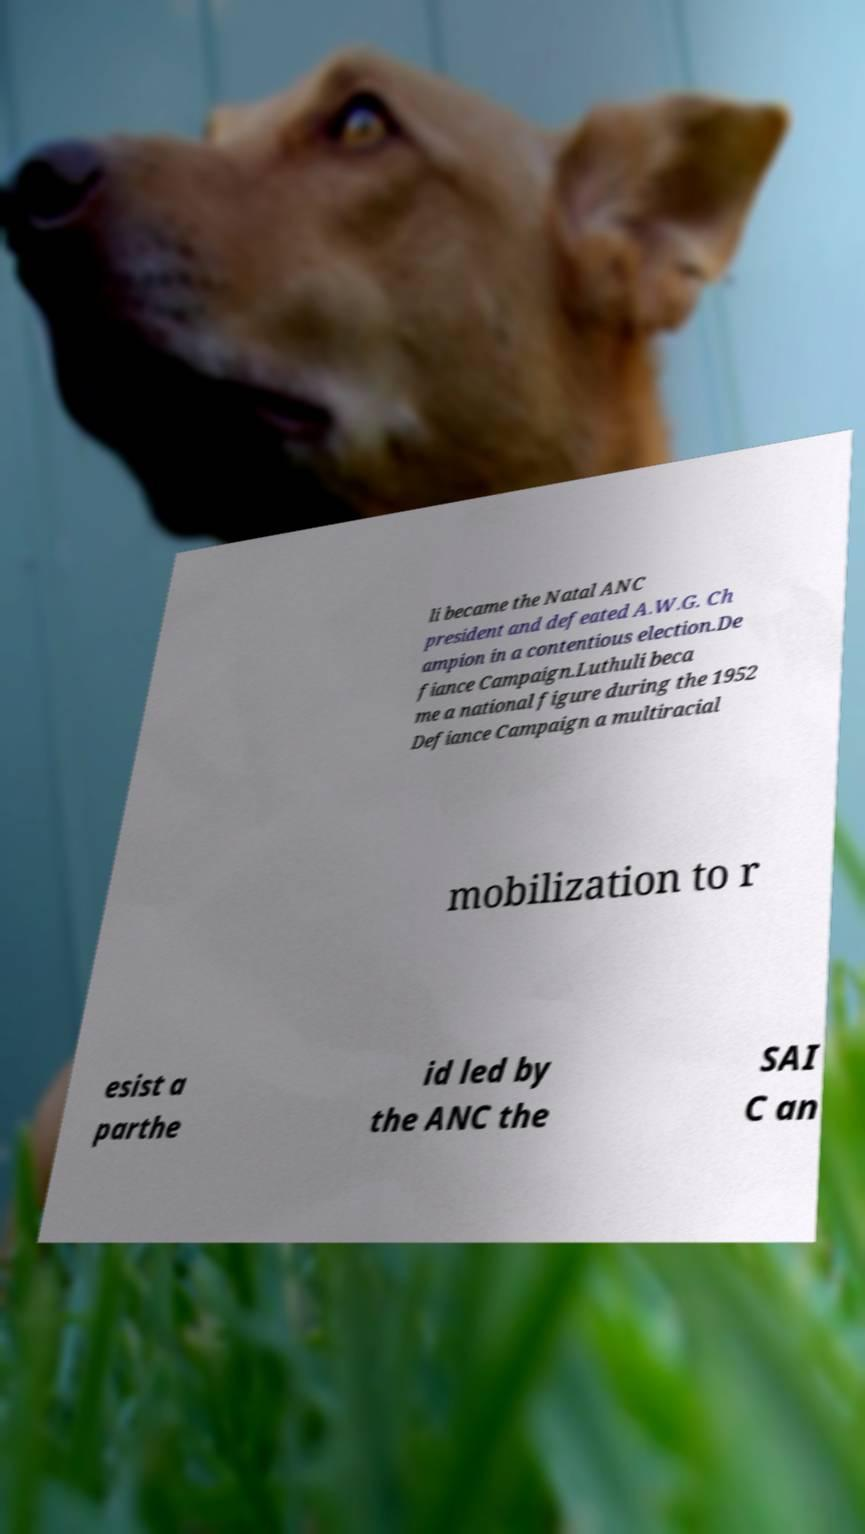I need the written content from this picture converted into text. Can you do that? li became the Natal ANC president and defeated A.W.G. Ch ampion in a contentious election.De fiance Campaign.Luthuli beca me a national figure during the 1952 Defiance Campaign a multiracial mobilization to r esist a parthe id led by the ANC the SAI C an 